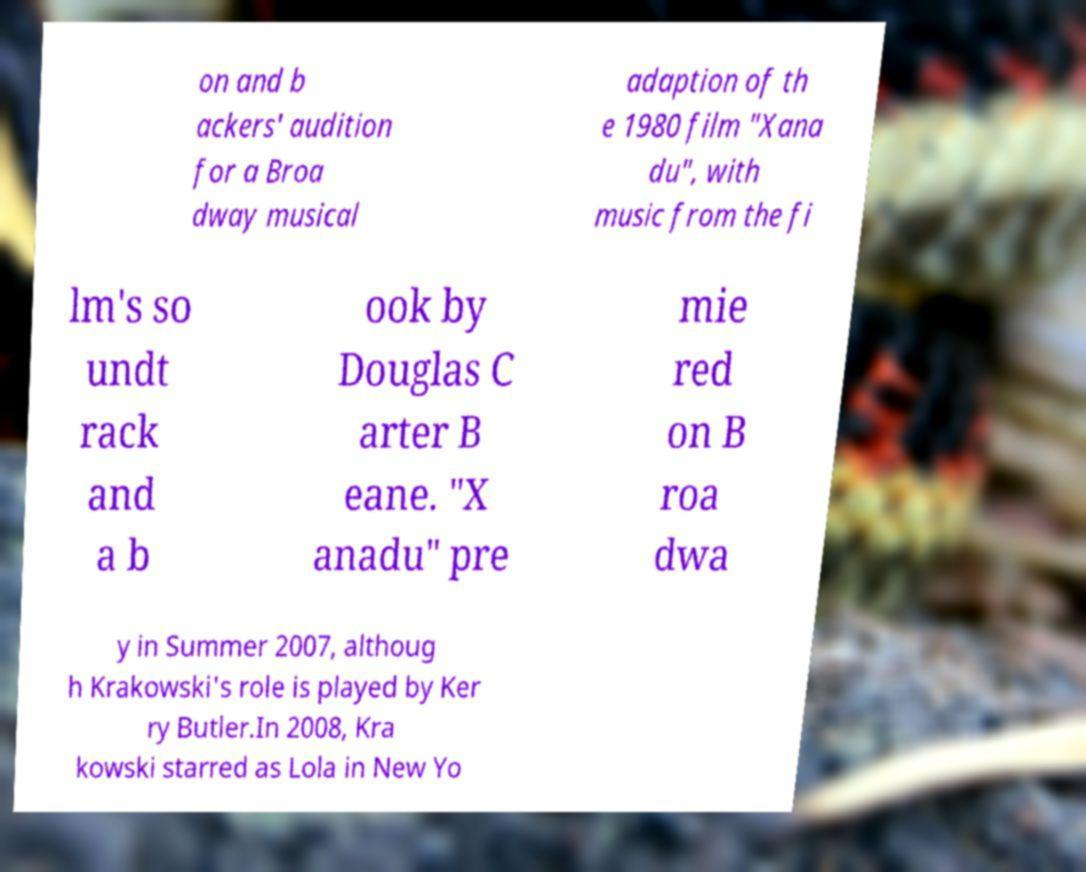Please read and relay the text visible in this image. What does it say? on and b ackers' audition for a Broa dway musical adaption of th e 1980 film "Xana du", with music from the fi lm's so undt rack and a b ook by Douglas C arter B eane. "X anadu" pre mie red on B roa dwa y in Summer 2007, althoug h Krakowski's role is played by Ker ry Butler.In 2008, Kra kowski starred as Lola in New Yo 